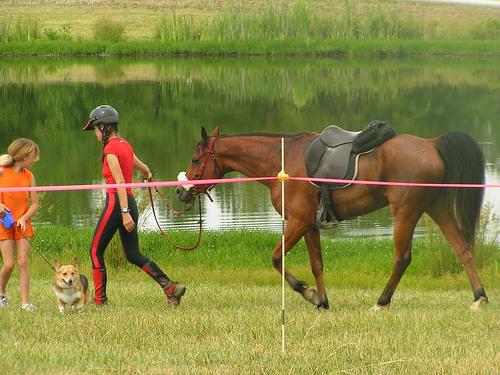What is around the horse's head?
Write a very short answer. Bridle. What animals can be seen?
Write a very short answer. Horse and dog. What is the girl in orange holding?
Short answer required. Dog. 